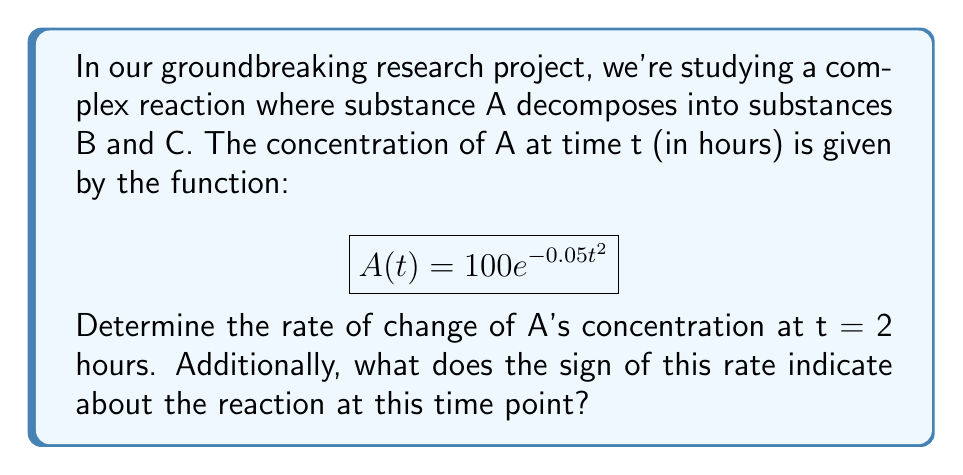Help me with this question. To solve this problem, we need to use derivatives to find the rate of change of A's concentration.

1) First, let's find the derivative of A(t) with respect to t:

   $$\frac{d}{dt}A(t) = \frac{d}{dt}(100e^{-0.05t^2})$$

   Using the chain rule:

   $$\frac{d}{dt}A(t) = 100 \cdot e^{-0.05t^2} \cdot (-0.1t)$$
   
   $$A'(t) = -10t \cdot e^{-0.05t^2}$$

2) Now, we need to evaluate this at t = 2:

   $$A'(2) = -10(2) \cdot e^{-0.05(2)^2}$$
   
   $$= -20 \cdot e^{-0.2}$$
   
   $$\approx -16.37$$

3) The units for this rate would be concentration per hour, which in this case is likely mol/L per hour.

4) The negative sign indicates that the concentration of A is decreasing at t = 2 hours, which is expected for a decomposition reaction.
Answer: The rate of change of A's concentration at t = 2 hours is approximately -16.37 mol/L per hour. The negative sign indicates that the concentration of A is decreasing at this time point, consistent with its decomposition into B and C. 